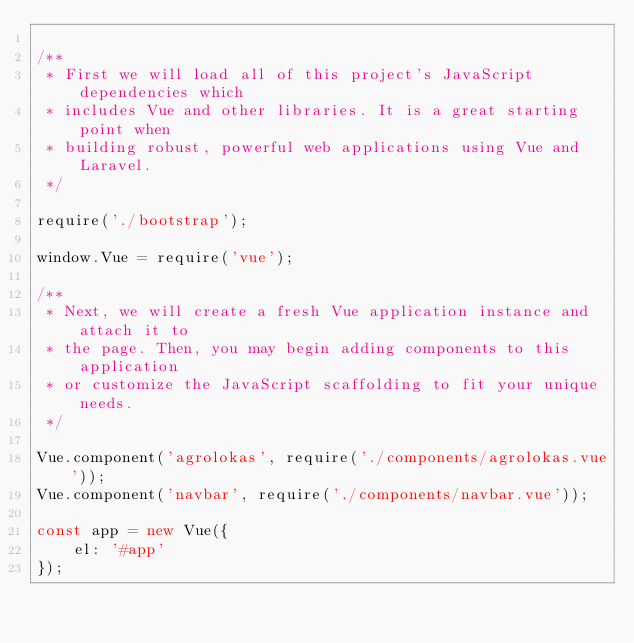<code> <loc_0><loc_0><loc_500><loc_500><_JavaScript_>
/**
 * First we will load all of this project's JavaScript dependencies which
 * includes Vue and other libraries. It is a great starting point when
 * building robust, powerful web applications using Vue and Laravel.
 */

require('./bootstrap');

window.Vue = require('vue');

/**
 * Next, we will create a fresh Vue application instance and attach it to
 * the page. Then, you may begin adding components to this application
 * or customize the JavaScript scaffolding to fit your unique needs.
 */

Vue.component('agrolokas', require('./components/agrolokas.vue'));
Vue.component('navbar', require('./components/navbar.vue'));

const app = new Vue({
    el: '#app'
});
</code> 